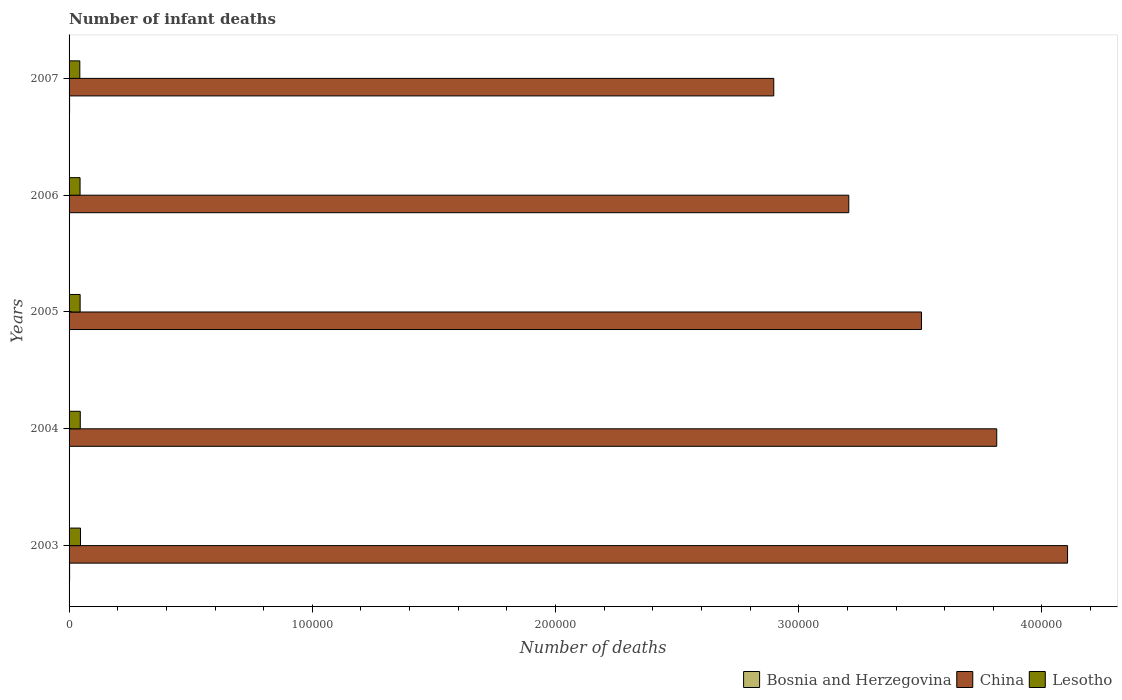How many different coloured bars are there?
Offer a terse response. 3. How many groups of bars are there?
Your answer should be compact. 5. How many bars are there on the 4th tick from the top?
Provide a short and direct response. 3. How many bars are there on the 4th tick from the bottom?
Your answer should be compact. 3. In how many cases, is the number of bars for a given year not equal to the number of legend labels?
Provide a short and direct response. 0. What is the number of infant deaths in Lesotho in 2006?
Keep it short and to the point. 4519. Across all years, what is the maximum number of infant deaths in China?
Your response must be concise. 4.11e+05. Across all years, what is the minimum number of infant deaths in China?
Make the answer very short. 2.90e+05. In which year was the number of infant deaths in Bosnia and Herzegovina maximum?
Provide a succinct answer. 2003. What is the total number of infant deaths in China in the graph?
Provide a short and direct response. 1.75e+06. What is the difference between the number of infant deaths in Lesotho in 2003 and that in 2006?
Offer a terse response. 187. What is the difference between the number of infant deaths in Bosnia and Herzegovina in 2007 and the number of infant deaths in China in 2003?
Give a very brief answer. -4.10e+05. What is the average number of infant deaths in Bosnia and Herzegovina per year?
Offer a very short reply. 191.6. In the year 2004, what is the difference between the number of infant deaths in Lesotho and number of infant deaths in Bosnia and Herzegovina?
Make the answer very short. 4420. In how many years, is the number of infant deaths in Bosnia and Herzegovina greater than 180000 ?
Ensure brevity in your answer.  0. What is the ratio of the number of infant deaths in China in 2003 to that in 2007?
Offer a terse response. 1.42. Is the difference between the number of infant deaths in Lesotho in 2003 and 2005 greater than the difference between the number of infant deaths in Bosnia and Herzegovina in 2003 and 2005?
Give a very brief answer. Yes. Is the sum of the number of infant deaths in Bosnia and Herzegovina in 2003 and 2007 greater than the maximum number of infant deaths in Lesotho across all years?
Your response must be concise. No. What does the 3rd bar from the top in 2007 represents?
Make the answer very short. Bosnia and Herzegovina. What does the 3rd bar from the bottom in 2005 represents?
Ensure brevity in your answer.  Lesotho. Are all the bars in the graph horizontal?
Keep it short and to the point. Yes. How many years are there in the graph?
Ensure brevity in your answer.  5. What is the difference between two consecutive major ticks on the X-axis?
Provide a short and direct response. 1.00e+05. Are the values on the major ticks of X-axis written in scientific E-notation?
Provide a short and direct response. No. Does the graph contain grids?
Keep it short and to the point. No. How many legend labels are there?
Give a very brief answer. 3. How are the legend labels stacked?
Keep it short and to the point. Horizontal. What is the title of the graph?
Ensure brevity in your answer.  Number of infant deaths. Does "Uganda" appear as one of the legend labels in the graph?
Provide a succinct answer. No. What is the label or title of the X-axis?
Your answer should be very brief. Number of deaths. What is the Number of deaths in Bosnia and Herzegovina in 2003?
Your answer should be compact. 220. What is the Number of deaths in China in 2003?
Offer a very short reply. 4.11e+05. What is the Number of deaths in Lesotho in 2003?
Provide a succinct answer. 4706. What is the Number of deaths of Bosnia and Herzegovina in 2004?
Ensure brevity in your answer.  182. What is the Number of deaths in China in 2004?
Give a very brief answer. 3.81e+05. What is the Number of deaths in Lesotho in 2004?
Provide a short and direct response. 4602. What is the Number of deaths in Bosnia and Herzegovina in 2005?
Offer a very short reply. 167. What is the Number of deaths of China in 2005?
Provide a short and direct response. 3.50e+05. What is the Number of deaths of Lesotho in 2005?
Offer a very short reply. 4542. What is the Number of deaths in Bosnia and Herzegovina in 2006?
Your answer should be very brief. 180. What is the Number of deaths in China in 2006?
Your answer should be compact. 3.21e+05. What is the Number of deaths in Lesotho in 2006?
Your answer should be compact. 4519. What is the Number of deaths in Bosnia and Herzegovina in 2007?
Keep it short and to the point. 209. What is the Number of deaths in China in 2007?
Ensure brevity in your answer.  2.90e+05. What is the Number of deaths of Lesotho in 2007?
Keep it short and to the point. 4415. Across all years, what is the maximum Number of deaths in Bosnia and Herzegovina?
Your answer should be very brief. 220. Across all years, what is the maximum Number of deaths in China?
Make the answer very short. 4.11e+05. Across all years, what is the maximum Number of deaths of Lesotho?
Offer a very short reply. 4706. Across all years, what is the minimum Number of deaths in Bosnia and Herzegovina?
Offer a terse response. 167. Across all years, what is the minimum Number of deaths in China?
Provide a short and direct response. 2.90e+05. Across all years, what is the minimum Number of deaths of Lesotho?
Make the answer very short. 4415. What is the total Number of deaths of Bosnia and Herzegovina in the graph?
Offer a terse response. 958. What is the total Number of deaths of China in the graph?
Your answer should be very brief. 1.75e+06. What is the total Number of deaths in Lesotho in the graph?
Provide a succinct answer. 2.28e+04. What is the difference between the Number of deaths in Bosnia and Herzegovina in 2003 and that in 2004?
Your response must be concise. 38. What is the difference between the Number of deaths of China in 2003 and that in 2004?
Ensure brevity in your answer.  2.91e+04. What is the difference between the Number of deaths in Lesotho in 2003 and that in 2004?
Your answer should be compact. 104. What is the difference between the Number of deaths of China in 2003 and that in 2005?
Your answer should be compact. 6.00e+04. What is the difference between the Number of deaths in Lesotho in 2003 and that in 2005?
Offer a terse response. 164. What is the difference between the Number of deaths in Bosnia and Herzegovina in 2003 and that in 2006?
Offer a very short reply. 40. What is the difference between the Number of deaths in China in 2003 and that in 2006?
Offer a terse response. 9.00e+04. What is the difference between the Number of deaths of Lesotho in 2003 and that in 2006?
Offer a very short reply. 187. What is the difference between the Number of deaths of China in 2003 and that in 2007?
Offer a very short reply. 1.21e+05. What is the difference between the Number of deaths of Lesotho in 2003 and that in 2007?
Your answer should be compact. 291. What is the difference between the Number of deaths in Bosnia and Herzegovina in 2004 and that in 2005?
Make the answer very short. 15. What is the difference between the Number of deaths in China in 2004 and that in 2005?
Make the answer very short. 3.09e+04. What is the difference between the Number of deaths in China in 2004 and that in 2006?
Your answer should be very brief. 6.08e+04. What is the difference between the Number of deaths of Lesotho in 2004 and that in 2006?
Ensure brevity in your answer.  83. What is the difference between the Number of deaths of China in 2004 and that in 2007?
Give a very brief answer. 9.17e+04. What is the difference between the Number of deaths in Lesotho in 2004 and that in 2007?
Provide a succinct answer. 187. What is the difference between the Number of deaths in China in 2005 and that in 2006?
Provide a succinct answer. 2.99e+04. What is the difference between the Number of deaths of Bosnia and Herzegovina in 2005 and that in 2007?
Your answer should be very brief. -42. What is the difference between the Number of deaths of China in 2005 and that in 2007?
Provide a succinct answer. 6.08e+04. What is the difference between the Number of deaths in Lesotho in 2005 and that in 2007?
Provide a succinct answer. 127. What is the difference between the Number of deaths of China in 2006 and that in 2007?
Your response must be concise. 3.08e+04. What is the difference between the Number of deaths of Lesotho in 2006 and that in 2007?
Provide a short and direct response. 104. What is the difference between the Number of deaths in Bosnia and Herzegovina in 2003 and the Number of deaths in China in 2004?
Offer a very short reply. -3.81e+05. What is the difference between the Number of deaths of Bosnia and Herzegovina in 2003 and the Number of deaths of Lesotho in 2004?
Give a very brief answer. -4382. What is the difference between the Number of deaths of China in 2003 and the Number of deaths of Lesotho in 2004?
Provide a succinct answer. 4.06e+05. What is the difference between the Number of deaths in Bosnia and Herzegovina in 2003 and the Number of deaths in China in 2005?
Provide a succinct answer. -3.50e+05. What is the difference between the Number of deaths of Bosnia and Herzegovina in 2003 and the Number of deaths of Lesotho in 2005?
Your answer should be very brief. -4322. What is the difference between the Number of deaths in China in 2003 and the Number of deaths in Lesotho in 2005?
Offer a very short reply. 4.06e+05. What is the difference between the Number of deaths in Bosnia and Herzegovina in 2003 and the Number of deaths in China in 2006?
Give a very brief answer. -3.20e+05. What is the difference between the Number of deaths in Bosnia and Herzegovina in 2003 and the Number of deaths in Lesotho in 2006?
Keep it short and to the point. -4299. What is the difference between the Number of deaths in China in 2003 and the Number of deaths in Lesotho in 2006?
Your answer should be compact. 4.06e+05. What is the difference between the Number of deaths of Bosnia and Herzegovina in 2003 and the Number of deaths of China in 2007?
Offer a very short reply. -2.90e+05. What is the difference between the Number of deaths in Bosnia and Herzegovina in 2003 and the Number of deaths in Lesotho in 2007?
Keep it short and to the point. -4195. What is the difference between the Number of deaths in China in 2003 and the Number of deaths in Lesotho in 2007?
Your response must be concise. 4.06e+05. What is the difference between the Number of deaths in Bosnia and Herzegovina in 2004 and the Number of deaths in China in 2005?
Give a very brief answer. -3.50e+05. What is the difference between the Number of deaths of Bosnia and Herzegovina in 2004 and the Number of deaths of Lesotho in 2005?
Offer a very short reply. -4360. What is the difference between the Number of deaths in China in 2004 and the Number of deaths in Lesotho in 2005?
Offer a very short reply. 3.77e+05. What is the difference between the Number of deaths in Bosnia and Herzegovina in 2004 and the Number of deaths in China in 2006?
Keep it short and to the point. -3.20e+05. What is the difference between the Number of deaths in Bosnia and Herzegovina in 2004 and the Number of deaths in Lesotho in 2006?
Keep it short and to the point. -4337. What is the difference between the Number of deaths of China in 2004 and the Number of deaths of Lesotho in 2006?
Offer a very short reply. 3.77e+05. What is the difference between the Number of deaths in Bosnia and Herzegovina in 2004 and the Number of deaths in China in 2007?
Offer a very short reply. -2.90e+05. What is the difference between the Number of deaths of Bosnia and Herzegovina in 2004 and the Number of deaths of Lesotho in 2007?
Your answer should be very brief. -4233. What is the difference between the Number of deaths of China in 2004 and the Number of deaths of Lesotho in 2007?
Keep it short and to the point. 3.77e+05. What is the difference between the Number of deaths in Bosnia and Herzegovina in 2005 and the Number of deaths in China in 2006?
Offer a very short reply. -3.20e+05. What is the difference between the Number of deaths in Bosnia and Herzegovina in 2005 and the Number of deaths in Lesotho in 2006?
Ensure brevity in your answer.  -4352. What is the difference between the Number of deaths in China in 2005 and the Number of deaths in Lesotho in 2006?
Your answer should be very brief. 3.46e+05. What is the difference between the Number of deaths of Bosnia and Herzegovina in 2005 and the Number of deaths of China in 2007?
Offer a terse response. -2.90e+05. What is the difference between the Number of deaths of Bosnia and Herzegovina in 2005 and the Number of deaths of Lesotho in 2007?
Offer a terse response. -4248. What is the difference between the Number of deaths in China in 2005 and the Number of deaths in Lesotho in 2007?
Your answer should be compact. 3.46e+05. What is the difference between the Number of deaths of Bosnia and Herzegovina in 2006 and the Number of deaths of China in 2007?
Make the answer very short. -2.90e+05. What is the difference between the Number of deaths of Bosnia and Herzegovina in 2006 and the Number of deaths of Lesotho in 2007?
Provide a short and direct response. -4235. What is the difference between the Number of deaths of China in 2006 and the Number of deaths of Lesotho in 2007?
Your response must be concise. 3.16e+05. What is the average Number of deaths of Bosnia and Herzegovina per year?
Your answer should be compact. 191.6. What is the average Number of deaths of China per year?
Give a very brief answer. 3.51e+05. What is the average Number of deaths of Lesotho per year?
Offer a terse response. 4556.8. In the year 2003, what is the difference between the Number of deaths of Bosnia and Herzegovina and Number of deaths of China?
Offer a very short reply. -4.10e+05. In the year 2003, what is the difference between the Number of deaths in Bosnia and Herzegovina and Number of deaths in Lesotho?
Offer a terse response. -4486. In the year 2003, what is the difference between the Number of deaths in China and Number of deaths in Lesotho?
Make the answer very short. 4.06e+05. In the year 2004, what is the difference between the Number of deaths of Bosnia and Herzegovina and Number of deaths of China?
Provide a short and direct response. -3.81e+05. In the year 2004, what is the difference between the Number of deaths in Bosnia and Herzegovina and Number of deaths in Lesotho?
Provide a short and direct response. -4420. In the year 2004, what is the difference between the Number of deaths in China and Number of deaths in Lesotho?
Ensure brevity in your answer.  3.77e+05. In the year 2005, what is the difference between the Number of deaths in Bosnia and Herzegovina and Number of deaths in China?
Make the answer very short. -3.50e+05. In the year 2005, what is the difference between the Number of deaths of Bosnia and Herzegovina and Number of deaths of Lesotho?
Offer a terse response. -4375. In the year 2005, what is the difference between the Number of deaths of China and Number of deaths of Lesotho?
Your answer should be compact. 3.46e+05. In the year 2006, what is the difference between the Number of deaths in Bosnia and Herzegovina and Number of deaths in China?
Provide a short and direct response. -3.20e+05. In the year 2006, what is the difference between the Number of deaths in Bosnia and Herzegovina and Number of deaths in Lesotho?
Your answer should be very brief. -4339. In the year 2006, what is the difference between the Number of deaths in China and Number of deaths in Lesotho?
Keep it short and to the point. 3.16e+05. In the year 2007, what is the difference between the Number of deaths in Bosnia and Herzegovina and Number of deaths in China?
Keep it short and to the point. -2.90e+05. In the year 2007, what is the difference between the Number of deaths in Bosnia and Herzegovina and Number of deaths in Lesotho?
Provide a succinct answer. -4206. In the year 2007, what is the difference between the Number of deaths in China and Number of deaths in Lesotho?
Offer a very short reply. 2.85e+05. What is the ratio of the Number of deaths of Bosnia and Herzegovina in 2003 to that in 2004?
Provide a short and direct response. 1.21. What is the ratio of the Number of deaths of China in 2003 to that in 2004?
Offer a terse response. 1.08. What is the ratio of the Number of deaths in Lesotho in 2003 to that in 2004?
Your response must be concise. 1.02. What is the ratio of the Number of deaths in Bosnia and Herzegovina in 2003 to that in 2005?
Offer a terse response. 1.32. What is the ratio of the Number of deaths of China in 2003 to that in 2005?
Your answer should be compact. 1.17. What is the ratio of the Number of deaths in Lesotho in 2003 to that in 2005?
Give a very brief answer. 1.04. What is the ratio of the Number of deaths of Bosnia and Herzegovina in 2003 to that in 2006?
Your answer should be very brief. 1.22. What is the ratio of the Number of deaths of China in 2003 to that in 2006?
Your answer should be compact. 1.28. What is the ratio of the Number of deaths in Lesotho in 2003 to that in 2006?
Give a very brief answer. 1.04. What is the ratio of the Number of deaths of Bosnia and Herzegovina in 2003 to that in 2007?
Your answer should be compact. 1.05. What is the ratio of the Number of deaths in China in 2003 to that in 2007?
Make the answer very short. 1.42. What is the ratio of the Number of deaths of Lesotho in 2003 to that in 2007?
Make the answer very short. 1.07. What is the ratio of the Number of deaths in Bosnia and Herzegovina in 2004 to that in 2005?
Your response must be concise. 1.09. What is the ratio of the Number of deaths in China in 2004 to that in 2005?
Your answer should be compact. 1.09. What is the ratio of the Number of deaths in Lesotho in 2004 to that in 2005?
Provide a succinct answer. 1.01. What is the ratio of the Number of deaths of Bosnia and Herzegovina in 2004 to that in 2006?
Keep it short and to the point. 1.01. What is the ratio of the Number of deaths of China in 2004 to that in 2006?
Keep it short and to the point. 1.19. What is the ratio of the Number of deaths in Lesotho in 2004 to that in 2006?
Give a very brief answer. 1.02. What is the ratio of the Number of deaths of Bosnia and Herzegovina in 2004 to that in 2007?
Keep it short and to the point. 0.87. What is the ratio of the Number of deaths of China in 2004 to that in 2007?
Provide a succinct answer. 1.32. What is the ratio of the Number of deaths of Lesotho in 2004 to that in 2007?
Provide a succinct answer. 1.04. What is the ratio of the Number of deaths in Bosnia and Herzegovina in 2005 to that in 2006?
Your answer should be very brief. 0.93. What is the ratio of the Number of deaths in China in 2005 to that in 2006?
Give a very brief answer. 1.09. What is the ratio of the Number of deaths of Lesotho in 2005 to that in 2006?
Your answer should be very brief. 1.01. What is the ratio of the Number of deaths of Bosnia and Herzegovina in 2005 to that in 2007?
Your answer should be very brief. 0.8. What is the ratio of the Number of deaths in China in 2005 to that in 2007?
Offer a terse response. 1.21. What is the ratio of the Number of deaths in Lesotho in 2005 to that in 2007?
Provide a short and direct response. 1.03. What is the ratio of the Number of deaths of Bosnia and Herzegovina in 2006 to that in 2007?
Provide a short and direct response. 0.86. What is the ratio of the Number of deaths in China in 2006 to that in 2007?
Provide a succinct answer. 1.11. What is the ratio of the Number of deaths of Lesotho in 2006 to that in 2007?
Keep it short and to the point. 1.02. What is the difference between the highest and the second highest Number of deaths in Bosnia and Herzegovina?
Make the answer very short. 11. What is the difference between the highest and the second highest Number of deaths in China?
Keep it short and to the point. 2.91e+04. What is the difference between the highest and the second highest Number of deaths in Lesotho?
Make the answer very short. 104. What is the difference between the highest and the lowest Number of deaths in Bosnia and Herzegovina?
Provide a succinct answer. 53. What is the difference between the highest and the lowest Number of deaths in China?
Keep it short and to the point. 1.21e+05. What is the difference between the highest and the lowest Number of deaths of Lesotho?
Make the answer very short. 291. 